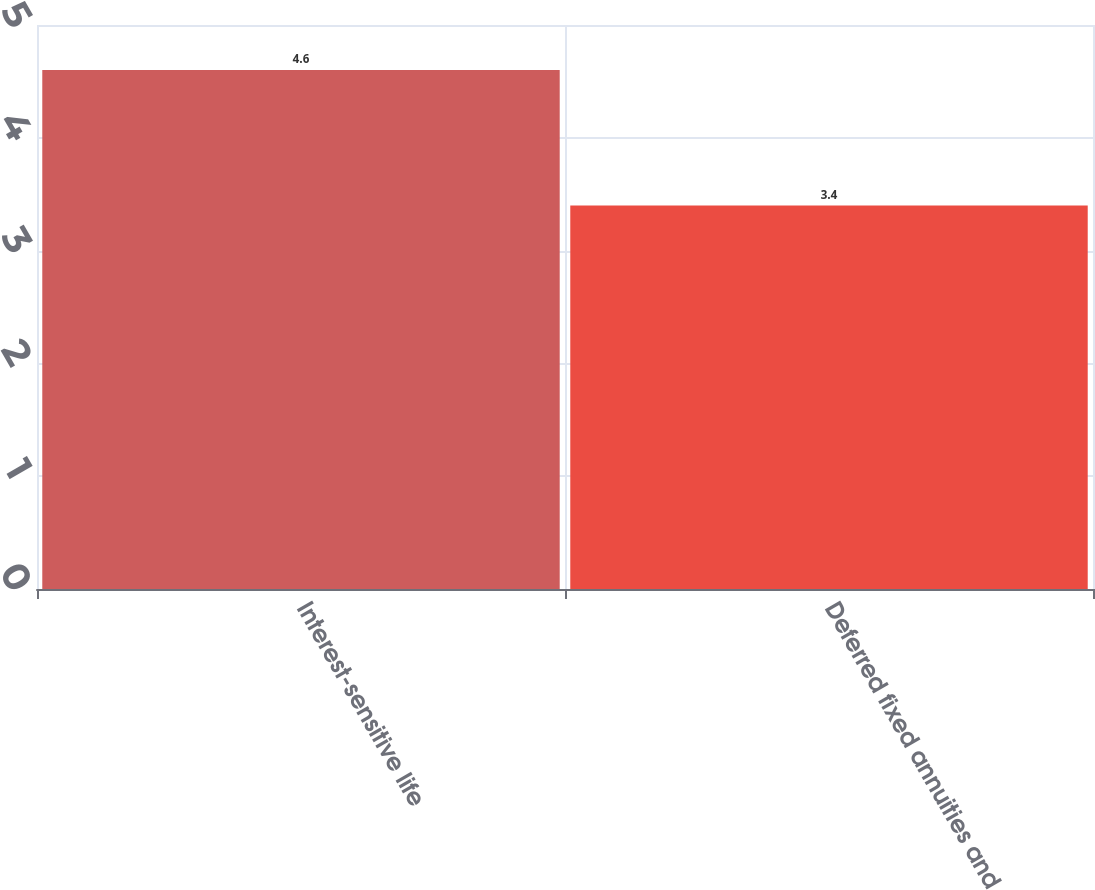Convert chart to OTSL. <chart><loc_0><loc_0><loc_500><loc_500><bar_chart><fcel>Interest-sensitive life<fcel>Deferred fixed annuities and<nl><fcel>4.6<fcel>3.4<nl></chart> 